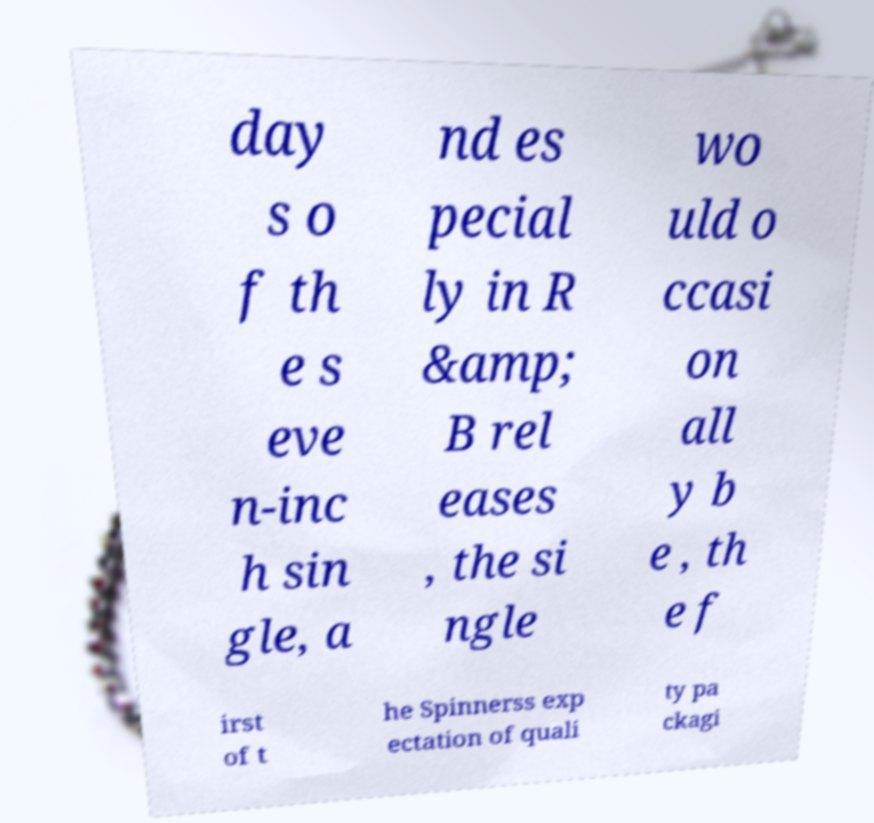Can you accurately transcribe the text from the provided image for me? day s o f th e s eve n-inc h sin gle, a nd es pecial ly in R &amp; B rel eases , the si ngle wo uld o ccasi on all y b e , th e f irst of t he Spinnerss exp ectation of quali ty pa ckagi 